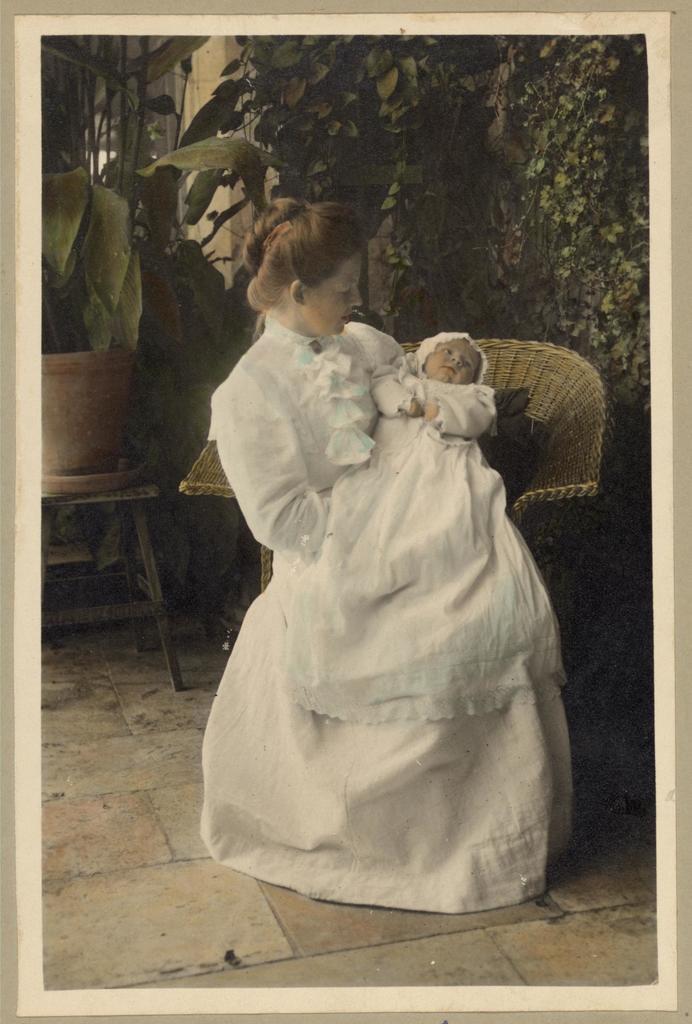Could you give a brief overview of what you see in this image? In this image in front there is a woman holding the baby. Behind her there is a chair. There is a table. There is a flower pot on the chair. In the background of the image there are trees. There is a wall. At the bottom of the image there is a floor. 